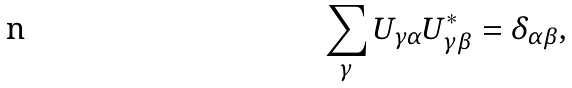Convert formula to latex. <formula><loc_0><loc_0><loc_500><loc_500>\sum _ { \gamma } U _ { \gamma \alpha } U _ { \gamma \beta } ^ { \ast } = \delta _ { \alpha \beta } ,</formula> 